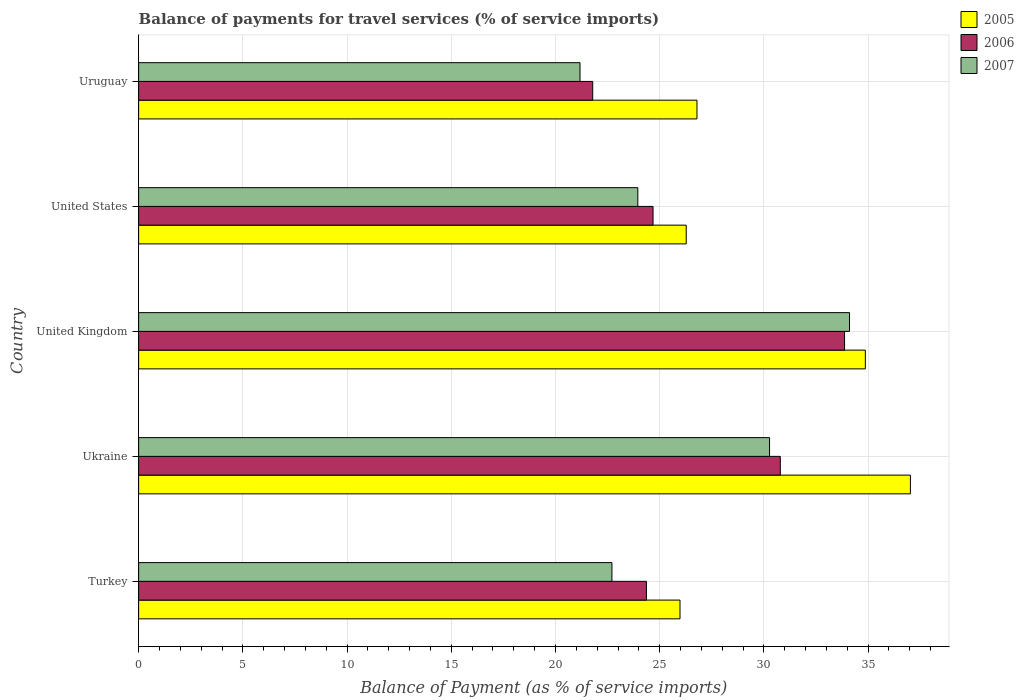How many different coloured bars are there?
Ensure brevity in your answer.  3. Are the number of bars per tick equal to the number of legend labels?
Your answer should be compact. Yes. Are the number of bars on each tick of the Y-axis equal?
Give a very brief answer. Yes. What is the label of the 2nd group of bars from the top?
Your answer should be compact. United States. In how many cases, is the number of bars for a given country not equal to the number of legend labels?
Provide a succinct answer. 0. What is the balance of payments for travel services in 2006 in Uruguay?
Give a very brief answer. 21.79. Across all countries, what is the maximum balance of payments for travel services in 2006?
Your response must be concise. 33.87. Across all countries, what is the minimum balance of payments for travel services in 2005?
Your answer should be very brief. 25.97. In which country was the balance of payments for travel services in 2007 minimum?
Your answer should be very brief. Uruguay. What is the total balance of payments for travel services in 2006 in the graph?
Provide a short and direct response. 135.49. What is the difference between the balance of payments for travel services in 2005 in United Kingdom and that in Uruguay?
Your answer should be compact. 8.08. What is the difference between the balance of payments for travel services in 2007 in United Kingdom and the balance of payments for travel services in 2005 in Ukraine?
Your answer should be very brief. -2.92. What is the average balance of payments for travel services in 2006 per country?
Ensure brevity in your answer.  27.1. What is the difference between the balance of payments for travel services in 2006 and balance of payments for travel services in 2007 in Uruguay?
Offer a terse response. 0.61. What is the ratio of the balance of payments for travel services in 2006 in Turkey to that in Ukraine?
Your answer should be compact. 0.79. What is the difference between the highest and the second highest balance of payments for travel services in 2007?
Make the answer very short. 3.84. What is the difference between the highest and the lowest balance of payments for travel services in 2007?
Provide a succinct answer. 12.93. What does the 1st bar from the top in Ukraine represents?
Your answer should be compact. 2007. What does the 2nd bar from the bottom in United Kingdom represents?
Ensure brevity in your answer.  2006. Is it the case that in every country, the sum of the balance of payments for travel services in 2005 and balance of payments for travel services in 2007 is greater than the balance of payments for travel services in 2006?
Offer a terse response. Yes. How many bars are there?
Offer a terse response. 15. What is the difference between two consecutive major ticks on the X-axis?
Provide a short and direct response. 5. Does the graph contain grids?
Your answer should be compact. Yes. Where does the legend appear in the graph?
Offer a very short reply. Top right. How are the legend labels stacked?
Offer a terse response. Vertical. What is the title of the graph?
Provide a succinct answer. Balance of payments for travel services (% of service imports). Does "2005" appear as one of the legend labels in the graph?
Make the answer very short. Yes. What is the label or title of the X-axis?
Ensure brevity in your answer.  Balance of Payment (as % of service imports). What is the label or title of the Y-axis?
Keep it short and to the point. Country. What is the Balance of Payment (as % of service imports) of 2005 in Turkey?
Your answer should be very brief. 25.97. What is the Balance of Payment (as % of service imports) in 2006 in Turkey?
Your answer should be very brief. 24.36. What is the Balance of Payment (as % of service imports) of 2007 in Turkey?
Give a very brief answer. 22.71. What is the Balance of Payment (as % of service imports) in 2005 in Ukraine?
Offer a terse response. 37.03. What is the Balance of Payment (as % of service imports) in 2006 in Ukraine?
Offer a very short reply. 30.79. What is the Balance of Payment (as % of service imports) of 2007 in Ukraine?
Give a very brief answer. 30.27. What is the Balance of Payment (as % of service imports) in 2005 in United Kingdom?
Keep it short and to the point. 34.87. What is the Balance of Payment (as % of service imports) in 2006 in United Kingdom?
Provide a short and direct response. 33.87. What is the Balance of Payment (as % of service imports) in 2007 in United Kingdom?
Your answer should be very brief. 34.11. What is the Balance of Payment (as % of service imports) of 2005 in United States?
Offer a terse response. 26.27. What is the Balance of Payment (as % of service imports) of 2006 in United States?
Make the answer very short. 24.68. What is the Balance of Payment (as % of service imports) of 2007 in United States?
Ensure brevity in your answer.  23.95. What is the Balance of Payment (as % of service imports) of 2005 in Uruguay?
Offer a terse response. 26.79. What is the Balance of Payment (as % of service imports) of 2006 in Uruguay?
Your answer should be compact. 21.79. What is the Balance of Payment (as % of service imports) in 2007 in Uruguay?
Your answer should be compact. 21.18. Across all countries, what is the maximum Balance of Payment (as % of service imports) in 2005?
Ensure brevity in your answer.  37.03. Across all countries, what is the maximum Balance of Payment (as % of service imports) in 2006?
Make the answer very short. 33.87. Across all countries, what is the maximum Balance of Payment (as % of service imports) in 2007?
Provide a short and direct response. 34.11. Across all countries, what is the minimum Balance of Payment (as % of service imports) of 2005?
Offer a terse response. 25.97. Across all countries, what is the minimum Balance of Payment (as % of service imports) of 2006?
Offer a very short reply. 21.79. Across all countries, what is the minimum Balance of Payment (as % of service imports) of 2007?
Provide a succinct answer. 21.18. What is the total Balance of Payment (as % of service imports) in 2005 in the graph?
Make the answer very short. 150.94. What is the total Balance of Payment (as % of service imports) in 2006 in the graph?
Your response must be concise. 135.49. What is the total Balance of Payment (as % of service imports) in 2007 in the graph?
Keep it short and to the point. 132.22. What is the difference between the Balance of Payment (as % of service imports) of 2005 in Turkey and that in Ukraine?
Your response must be concise. -11.05. What is the difference between the Balance of Payment (as % of service imports) of 2006 in Turkey and that in Ukraine?
Keep it short and to the point. -6.42. What is the difference between the Balance of Payment (as % of service imports) of 2007 in Turkey and that in Ukraine?
Your answer should be very brief. -7.56. What is the difference between the Balance of Payment (as % of service imports) of 2005 in Turkey and that in United Kingdom?
Offer a terse response. -8.89. What is the difference between the Balance of Payment (as % of service imports) in 2006 in Turkey and that in United Kingdom?
Offer a very short reply. -9.51. What is the difference between the Balance of Payment (as % of service imports) of 2007 in Turkey and that in United Kingdom?
Offer a very short reply. -11.4. What is the difference between the Balance of Payment (as % of service imports) in 2005 in Turkey and that in United States?
Ensure brevity in your answer.  -0.3. What is the difference between the Balance of Payment (as % of service imports) in 2006 in Turkey and that in United States?
Provide a short and direct response. -0.32. What is the difference between the Balance of Payment (as % of service imports) of 2007 in Turkey and that in United States?
Offer a very short reply. -1.24. What is the difference between the Balance of Payment (as % of service imports) of 2005 in Turkey and that in Uruguay?
Offer a terse response. -0.81. What is the difference between the Balance of Payment (as % of service imports) in 2006 in Turkey and that in Uruguay?
Ensure brevity in your answer.  2.58. What is the difference between the Balance of Payment (as % of service imports) in 2007 in Turkey and that in Uruguay?
Your response must be concise. 1.53. What is the difference between the Balance of Payment (as % of service imports) of 2005 in Ukraine and that in United Kingdom?
Provide a short and direct response. 2.16. What is the difference between the Balance of Payment (as % of service imports) of 2006 in Ukraine and that in United Kingdom?
Keep it short and to the point. -3.08. What is the difference between the Balance of Payment (as % of service imports) of 2007 in Ukraine and that in United Kingdom?
Offer a terse response. -3.84. What is the difference between the Balance of Payment (as % of service imports) in 2005 in Ukraine and that in United States?
Provide a short and direct response. 10.76. What is the difference between the Balance of Payment (as % of service imports) of 2006 in Ukraine and that in United States?
Give a very brief answer. 6.11. What is the difference between the Balance of Payment (as % of service imports) in 2007 in Ukraine and that in United States?
Make the answer very short. 6.32. What is the difference between the Balance of Payment (as % of service imports) in 2005 in Ukraine and that in Uruguay?
Provide a succinct answer. 10.24. What is the difference between the Balance of Payment (as % of service imports) of 2006 in Ukraine and that in Uruguay?
Offer a very short reply. 9. What is the difference between the Balance of Payment (as % of service imports) of 2007 in Ukraine and that in Uruguay?
Make the answer very short. 9.09. What is the difference between the Balance of Payment (as % of service imports) in 2005 in United Kingdom and that in United States?
Make the answer very short. 8.59. What is the difference between the Balance of Payment (as % of service imports) in 2006 in United Kingdom and that in United States?
Keep it short and to the point. 9.19. What is the difference between the Balance of Payment (as % of service imports) of 2007 in United Kingdom and that in United States?
Provide a short and direct response. 10.16. What is the difference between the Balance of Payment (as % of service imports) in 2005 in United Kingdom and that in Uruguay?
Provide a short and direct response. 8.08. What is the difference between the Balance of Payment (as % of service imports) in 2006 in United Kingdom and that in Uruguay?
Make the answer very short. 12.08. What is the difference between the Balance of Payment (as % of service imports) of 2007 in United Kingdom and that in Uruguay?
Offer a terse response. 12.93. What is the difference between the Balance of Payment (as % of service imports) in 2005 in United States and that in Uruguay?
Keep it short and to the point. -0.52. What is the difference between the Balance of Payment (as % of service imports) of 2006 in United States and that in Uruguay?
Give a very brief answer. 2.89. What is the difference between the Balance of Payment (as % of service imports) of 2007 in United States and that in Uruguay?
Your answer should be compact. 2.77. What is the difference between the Balance of Payment (as % of service imports) in 2005 in Turkey and the Balance of Payment (as % of service imports) in 2006 in Ukraine?
Your answer should be very brief. -4.81. What is the difference between the Balance of Payment (as % of service imports) of 2005 in Turkey and the Balance of Payment (as % of service imports) of 2007 in Ukraine?
Ensure brevity in your answer.  -4.3. What is the difference between the Balance of Payment (as % of service imports) in 2006 in Turkey and the Balance of Payment (as % of service imports) in 2007 in Ukraine?
Offer a very short reply. -5.91. What is the difference between the Balance of Payment (as % of service imports) of 2005 in Turkey and the Balance of Payment (as % of service imports) of 2006 in United Kingdom?
Give a very brief answer. -7.9. What is the difference between the Balance of Payment (as % of service imports) in 2005 in Turkey and the Balance of Payment (as % of service imports) in 2007 in United Kingdom?
Offer a terse response. -8.13. What is the difference between the Balance of Payment (as % of service imports) of 2006 in Turkey and the Balance of Payment (as % of service imports) of 2007 in United Kingdom?
Give a very brief answer. -9.74. What is the difference between the Balance of Payment (as % of service imports) of 2005 in Turkey and the Balance of Payment (as % of service imports) of 2006 in United States?
Make the answer very short. 1.29. What is the difference between the Balance of Payment (as % of service imports) of 2005 in Turkey and the Balance of Payment (as % of service imports) of 2007 in United States?
Keep it short and to the point. 2.02. What is the difference between the Balance of Payment (as % of service imports) in 2006 in Turkey and the Balance of Payment (as % of service imports) in 2007 in United States?
Offer a terse response. 0.41. What is the difference between the Balance of Payment (as % of service imports) in 2005 in Turkey and the Balance of Payment (as % of service imports) in 2006 in Uruguay?
Your answer should be compact. 4.19. What is the difference between the Balance of Payment (as % of service imports) of 2005 in Turkey and the Balance of Payment (as % of service imports) of 2007 in Uruguay?
Ensure brevity in your answer.  4.8. What is the difference between the Balance of Payment (as % of service imports) in 2006 in Turkey and the Balance of Payment (as % of service imports) in 2007 in Uruguay?
Offer a very short reply. 3.19. What is the difference between the Balance of Payment (as % of service imports) in 2005 in Ukraine and the Balance of Payment (as % of service imports) in 2006 in United Kingdom?
Give a very brief answer. 3.16. What is the difference between the Balance of Payment (as % of service imports) in 2005 in Ukraine and the Balance of Payment (as % of service imports) in 2007 in United Kingdom?
Give a very brief answer. 2.92. What is the difference between the Balance of Payment (as % of service imports) in 2006 in Ukraine and the Balance of Payment (as % of service imports) in 2007 in United Kingdom?
Your answer should be very brief. -3.32. What is the difference between the Balance of Payment (as % of service imports) in 2005 in Ukraine and the Balance of Payment (as % of service imports) in 2006 in United States?
Your answer should be very brief. 12.35. What is the difference between the Balance of Payment (as % of service imports) of 2005 in Ukraine and the Balance of Payment (as % of service imports) of 2007 in United States?
Make the answer very short. 13.08. What is the difference between the Balance of Payment (as % of service imports) in 2006 in Ukraine and the Balance of Payment (as % of service imports) in 2007 in United States?
Give a very brief answer. 6.84. What is the difference between the Balance of Payment (as % of service imports) in 2005 in Ukraine and the Balance of Payment (as % of service imports) in 2006 in Uruguay?
Provide a succinct answer. 15.24. What is the difference between the Balance of Payment (as % of service imports) of 2005 in Ukraine and the Balance of Payment (as % of service imports) of 2007 in Uruguay?
Offer a very short reply. 15.85. What is the difference between the Balance of Payment (as % of service imports) in 2006 in Ukraine and the Balance of Payment (as % of service imports) in 2007 in Uruguay?
Ensure brevity in your answer.  9.61. What is the difference between the Balance of Payment (as % of service imports) in 2005 in United Kingdom and the Balance of Payment (as % of service imports) in 2006 in United States?
Offer a terse response. 10.19. What is the difference between the Balance of Payment (as % of service imports) in 2005 in United Kingdom and the Balance of Payment (as % of service imports) in 2007 in United States?
Your answer should be compact. 10.92. What is the difference between the Balance of Payment (as % of service imports) of 2006 in United Kingdom and the Balance of Payment (as % of service imports) of 2007 in United States?
Keep it short and to the point. 9.92. What is the difference between the Balance of Payment (as % of service imports) in 2005 in United Kingdom and the Balance of Payment (as % of service imports) in 2006 in Uruguay?
Keep it short and to the point. 13.08. What is the difference between the Balance of Payment (as % of service imports) of 2005 in United Kingdom and the Balance of Payment (as % of service imports) of 2007 in Uruguay?
Your answer should be compact. 13.69. What is the difference between the Balance of Payment (as % of service imports) of 2006 in United Kingdom and the Balance of Payment (as % of service imports) of 2007 in Uruguay?
Your answer should be compact. 12.69. What is the difference between the Balance of Payment (as % of service imports) in 2005 in United States and the Balance of Payment (as % of service imports) in 2006 in Uruguay?
Offer a very short reply. 4.49. What is the difference between the Balance of Payment (as % of service imports) in 2005 in United States and the Balance of Payment (as % of service imports) in 2007 in Uruguay?
Offer a very short reply. 5.1. What is the difference between the Balance of Payment (as % of service imports) in 2006 in United States and the Balance of Payment (as % of service imports) in 2007 in Uruguay?
Your response must be concise. 3.5. What is the average Balance of Payment (as % of service imports) in 2005 per country?
Ensure brevity in your answer.  30.19. What is the average Balance of Payment (as % of service imports) in 2006 per country?
Your response must be concise. 27.1. What is the average Balance of Payment (as % of service imports) of 2007 per country?
Give a very brief answer. 26.44. What is the difference between the Balance of Payment (as % of service imports) in 2005 and Balance of Payment (as % of service imports) in 2006 in Turkey?
Offer a terse response. 1.61. What is the difference between the Balance of Payment (as % of service imports) in 2005 and Balance of Payment (as % of service imports) in 2007 in Turkey?
Provide a succinct answer. 3.27. What is the difference between the Balance of Payment (as % of service imports) of 2006 and Balance of Payment (as % of service imports) of 2007 in Turkey?
Your response must be concise. 1.66. What is the difference between the Balance of Payment (as % of service imports) in 2005 and Balance of Payment (as % of service imports) in 2006 in Ukraine?
Give a very brief answer. 6.24. What is the difference between the Balance of Payment (as % of service imports) of 2005 and Balance of Payment (as % of service imports) of 2007 in Ukraine?
Ensure brevity in your answer.  6.76. What is the difference between the Balance of Payment (as % of service imports) in 2006 and Balance of Payment (as % of service imports) in 2007 in Ukraine?
Provide a succinct answer. 0.52. What is the difference between the Balance of Payment (as % of service imports) of 2005 and Balance of Payment (as % of service imports) of 2007 in United Kingdom?
Your answer should be very brief. 0.76. What is the difference between the Balance of Payment (as % of service imports) in 2006 and Balance of Payment (as % of service imports) in 2007 in United Kingdom?
Offer a very short reply. -0.24. What is the difference between the Balance of Payment (as % of service imports) of 2005 and Balance of Payment (as % of service imports) of 2006 in United States?
Your answer should be compact. 1.59. What is the difference between the Balance of Payment (as % of service imports) of 2005 and Balance of Payment (as % of service imports) of 2007 in United States?
Make the answer very short. 2.32. What is the difference between the Balance of Payment (as % of service imports) of 2006 and Balance of Payment (as % of service imports) of 2007 in United States?
Offer a very short reply. 0.73. What is the difference between the Balance of Payment (as % of service imports) in 2005 and Balance of Payment (as % of service imports) in 2006 in Uruguay?
Your answer should be very brief. 5. What is the difference between the Balance of Payment (as % of service imports) in 2005 and Balance of Payment (as % of service imports) in 2007 in Uruguay?
Give a very brief answer. 5.61. What is the difference between the Balance of Payment (as % of service imports) of 2006 and Balance of Payment (as % of service imports) of 2007 in Uruguay?
Provide a succinct answer. 0.61. What is the ratio of the Balance of Payment (as % of service imports) of 2005 in Turkey to that in Ukraine?
Give a very brief answer. 0.7. What is the ratio of the Balance of Payment (as % of service imports) in 2006 in Turkey to that in Ukraine?
Offer a very short reply. 0.79. What is the ratio of the Balance of Payment (as % of service imports) of 2007 in Turkey to that in Ukraine?
Your answer should be very brief. 0.75. What is the ratio of the Balance of Payment (as % of service imports) of 2005 in Turkey to that in United Kingdom?
Offer a terse response. 0.74. What is the ratio of the Balance of Payment (as % of service imports) of 2006 in Turkey to that in United Kingdom?
Provide a succinct answer. 0.72. What is the ratio of the Balance of Payment (as % of service imports) in 2007 in Turkey to that in United Kingdom?
Offer a very short reply. 0.67. What is the ratio of the Balance of Payment (as % of service imports) in 2006 in Turkey to that in United States?
Your response must be concise. 0.99. What is the ratio of the Balance of Payment (as % of service imports) of 2007 in Turkey to that in United States?
Offer a terse response. 0.95. What is the ratio of the Balance of Payment (as % of service imports) in 2005 in Turkey to that in Uruguay?
Make the answer very short. 0.97. What is the ratio of the Balance of Payment (as % of service imports) in 2006 in Turkey to that in Uruguay?
Keep it short and to the point. 1.12. What is the ratio of the Balance of Payment (as % of service imports) in 2007 in Turkey to that in Uruguay?
Your response must be concise. 1.07. What is the ratio of the Balance of Payment (as % of service imports) of 2005 in Ukraine to that in United Kingdom?
Your response must be concise. 1.06. What is the ratio of the Balance of Payment (as % of service imports) in 2006 in Ukraine to that in United Kingdom?
Your answer should be compact. 0.91. What is the ratio of the Balance of Payment (as % of service imports) in 2007 in Ukraine to that in United Kingdom?
Give a very brief answer. 0.89. What is the ratio of the Balance of Payment (as % of service imports) in 2005 in Ukraine to that in United States?
Offer a very short reply. 1.41. What is the ratio of the Balance of Payment (as % of service imports) in 2006 in Ukraine to that in United States?
Ensure brevity in your answer.  1.25. What is the ratio of the Balance of Payment (as % of service imports) of 2007 in Ukraine to that in United States?
Give a very brief answer. 1.26. What is the ratio of the Balance of Payment (as % of service imports) in 2005 in Ukraine to that in Uruguay?
Give a very brief answer. 1.38. What is the ratio of the Balance of Payment (as % of service imports) in 2006 in Ukraine to that in Uruguay?
Provide a succinct answer. 1.41. What is the ratio of the Balance of Payment (as % of service imports) in 2007 in Ukraine to that in Uruguay?
Provide a short and direct response. 1.43. What is the ratio of the Balance of Payment (as % of service imports) of 2005 in United Kingdom to that in United States?
Provide a short and direct response. 1.33. What is the ratio of the Balance of Payment (as % of service imports) of 2006 in United Kingdom to that in United States?
Provide a short and direct response. 1.37. What is the ratio of the Balance of Payment (as % of service imports) of 2007 in United Kingdom to that in United States?
Provide a short and direct response. 1.42. What is the ratio of the Balance of Payment (as % of service imports) of 2005 in United Kingdom to that in Uruguay?
Keep it short and to the point. 1.3. What is the ratio of the Balance of Payment (as % of service imports) in 2006 in United Kingdom to that in Uruguay?
Your answer should be very brief. 1.55. What is the ratio of the Balance of Payment (as % of service imports) of 2007 in United Kingdom to that in Uruguay?
Your response must be concise. 1.61. What is the ratio of the Balance of Payment (as % of service imports) in 2005 in United States to that in Uruguay?
Your answer should be compact. 0.98. What is the ratio of the Balance of Payment (as % of service imports) in 2006 in United States to that in Uruguay?
Offer a terse response. 1.13. What is the ratio of the Balance of Payment (as % of service imports) in 2007 in United States to that in Uruguay?
Provide a short and direct response. 1.13. What is the difference between the highest and the second highest Balance of Payment (as % of service imports) in 2005?
Keep it short and to the point. 2.16. What is the difference between the highest and the second highest Balance of Payment (as % of service imports) in 2006?
Offer a terse response. 3.08. What is the difference between the highest and the second highest Balance of Payment (as % of service imports) in 2007?
Your answer should be compact. 3.84. What is the difference between the highest and the lowest Balance of Payment (as % of service imports) of 2005?
Your response must be concise. 11.05. What is the difference between the highest and the lowest Balance of Payment (as % of service imports) in 2006?
Give a very brief answer. 12.08. What is the difference between the highest and the lowest Balance of Payment (as % of service imports) of 2007?
Make the answer very short. 12.93. 